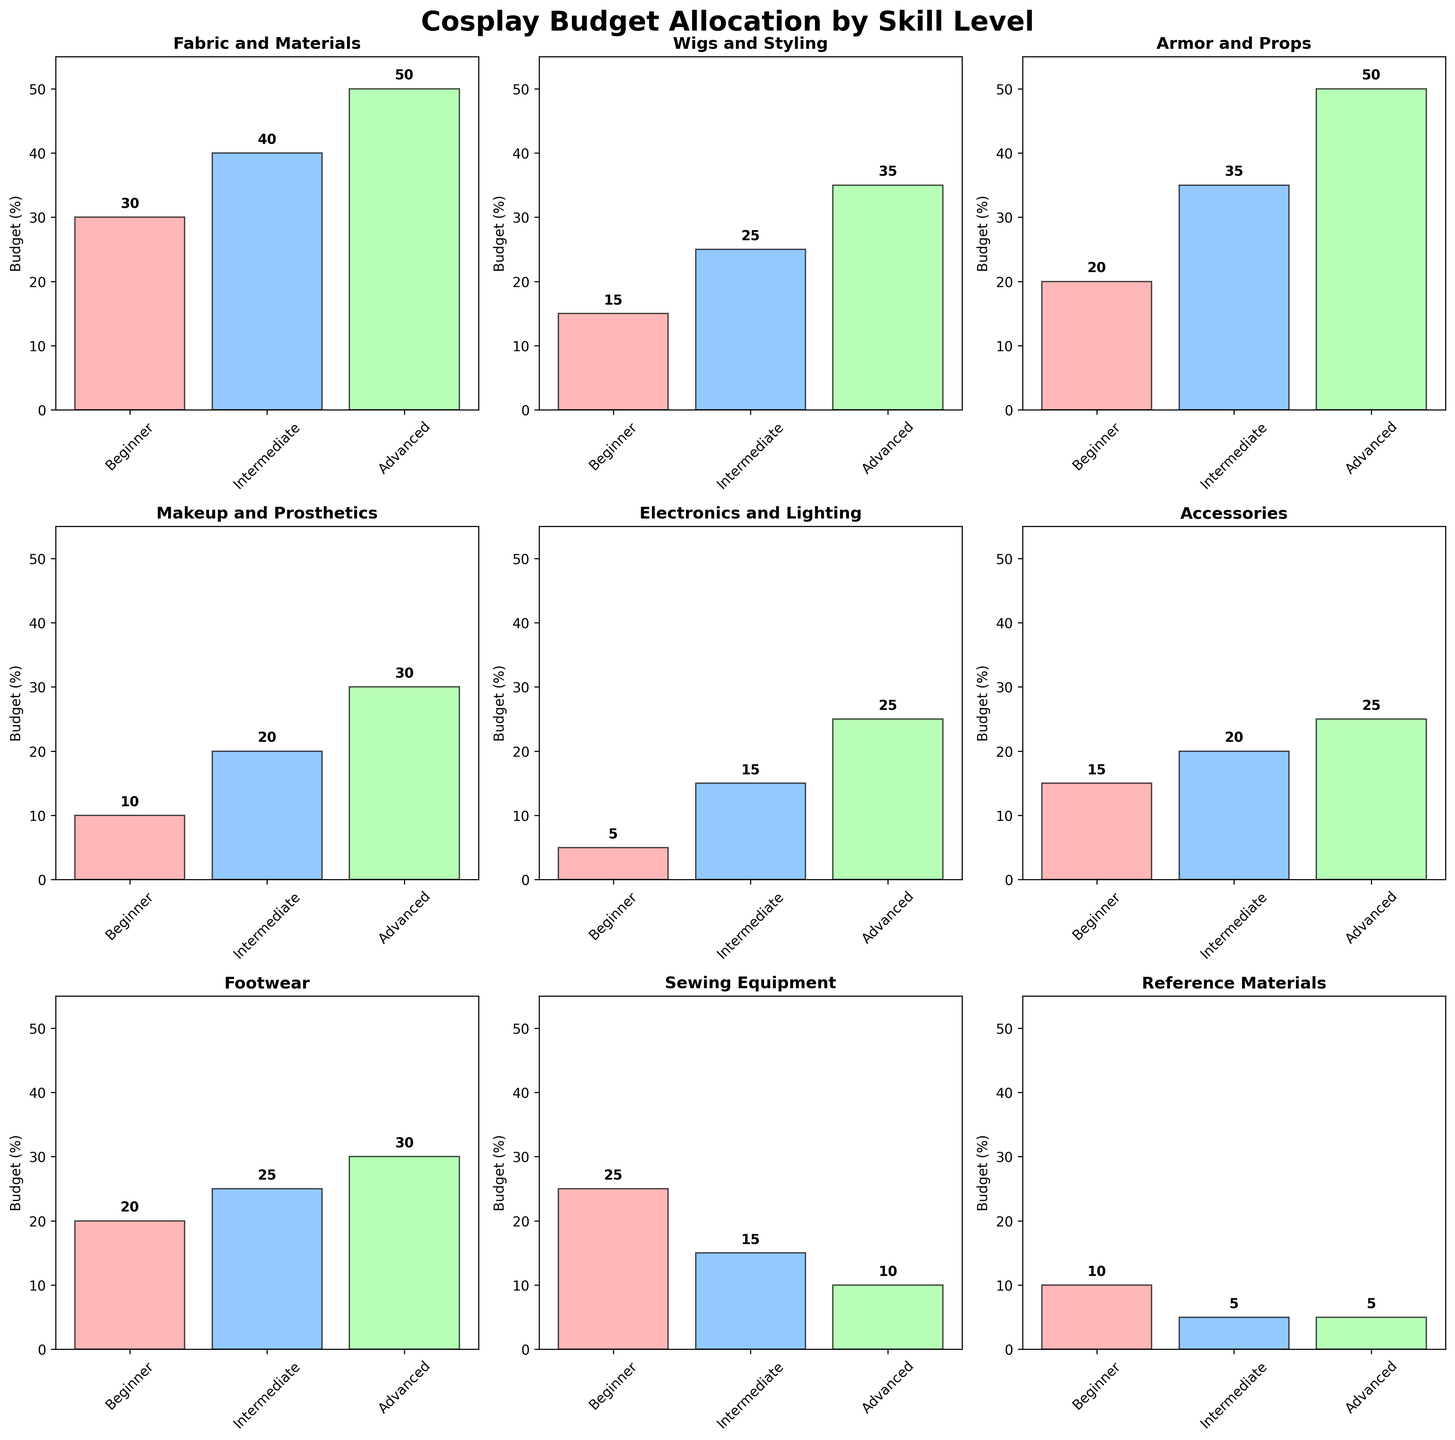What is the highest budget allocation for Electronic and Lighting at the Beginner level? Look at the subplot for "Electronics and Lighting" and the bar representing the Beginner level. The value on this bar is the budget allocation for this component at the Beginner level.
Answer: 5 Which skill level has the highest budget allocation for Armor and Props? Look at the subplot for "Armor and Props" and compare the heights of the bars for Beginner, Intermediate, and Advanced levels. The tallest bar represents the highest budget allocation.
Answer: Advanced What is the total budget allocation for Accessories at the Intermediate level and Advanced level? Look at the subplot for "Accessories" and add the values of the bars representing Intermediate level and Advanced level.
Answer: 20 + 25 = 45 How does the budget allocation for Makeup and Prosthetics change from Beginner to Advanced level? Observe the subplot for "Makeup and Prosthetics" and compare the heights of the bars for Beginner, Intermediate, and Advanced levels. Note the increase in values.
Answer: 10 to 20 to 30 Which component has the smallest budget allocation for Intermediate level? Compare the values of all the subplots for the Intermediate level bars and identify the smallest value.
Answer: Reference Materials What is the average budget allocation for Fabric and Materials across all skill levels? Look at the Fabric and Materials subplot and find the values for Beginner, Intermediate, and Advanced levels. Calculate the average of these three values.
Answer: (30 + 40 + 50) / 3 = 40 Which two components have the same budget allocation at the Beginner level? Compare the values of all the subplots for the Beginner level bars and identify any that are the same.
Answer: Reference Materials and Makeup and Prosthetics What is the difference in budget allocation for Wigs and Styling between Intermediate and Beginner levels? Look at the Wigs and Styling subplot and note the values for Intermediate and Beginner levels. Subtract the Beginner value from the Intermediate value.
Answer: 25 - 15 = 10 By how much does the budget allocation for Sewing Equipment decrease from Beginner to Advanced level? Observe the Sewing Equipment subplot and note the values for Beginner and Advanced levels. Subtract the Advanced value from the Beginner value.
Answer: 25 - 10 = 15 